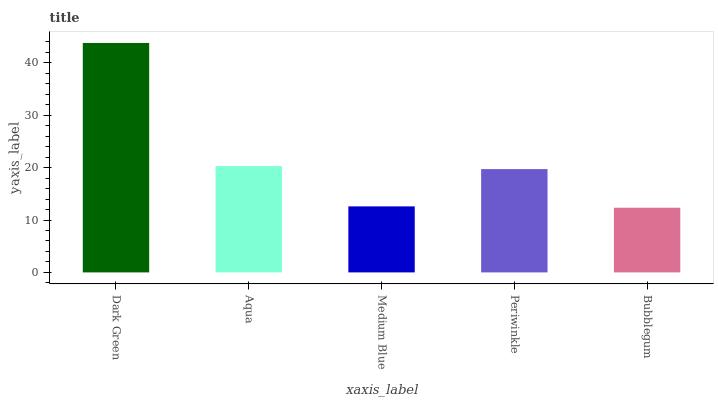Is Bubblegum the minimum?
Answer yes or no. Yes. Is Dark Green the maximum?
Answer yes or no. Yes. Is Aqua the minimum?
Answer yes or no. No. Is Aqua the maximum?
Answer yes or no. No. Is Dark Green greater than Aqua?
Answer yes or no. Yes. Is Aqua less than Dark Green?
Answer yes or no. Yes. Is Aqua greater than Dark Green?
Answer yes or no. No. Is Dark Green less than Aqua?
Answer yes or no. No. Is Periwinkle the high median?
Answer yes or no. Yes. Is Periwinkle the low median?
Answer yes or no. Yes. Is Medium Blue the high median?
Answer yes or no. No. Is Dark Green the low median?
Answer yes or no. No. 